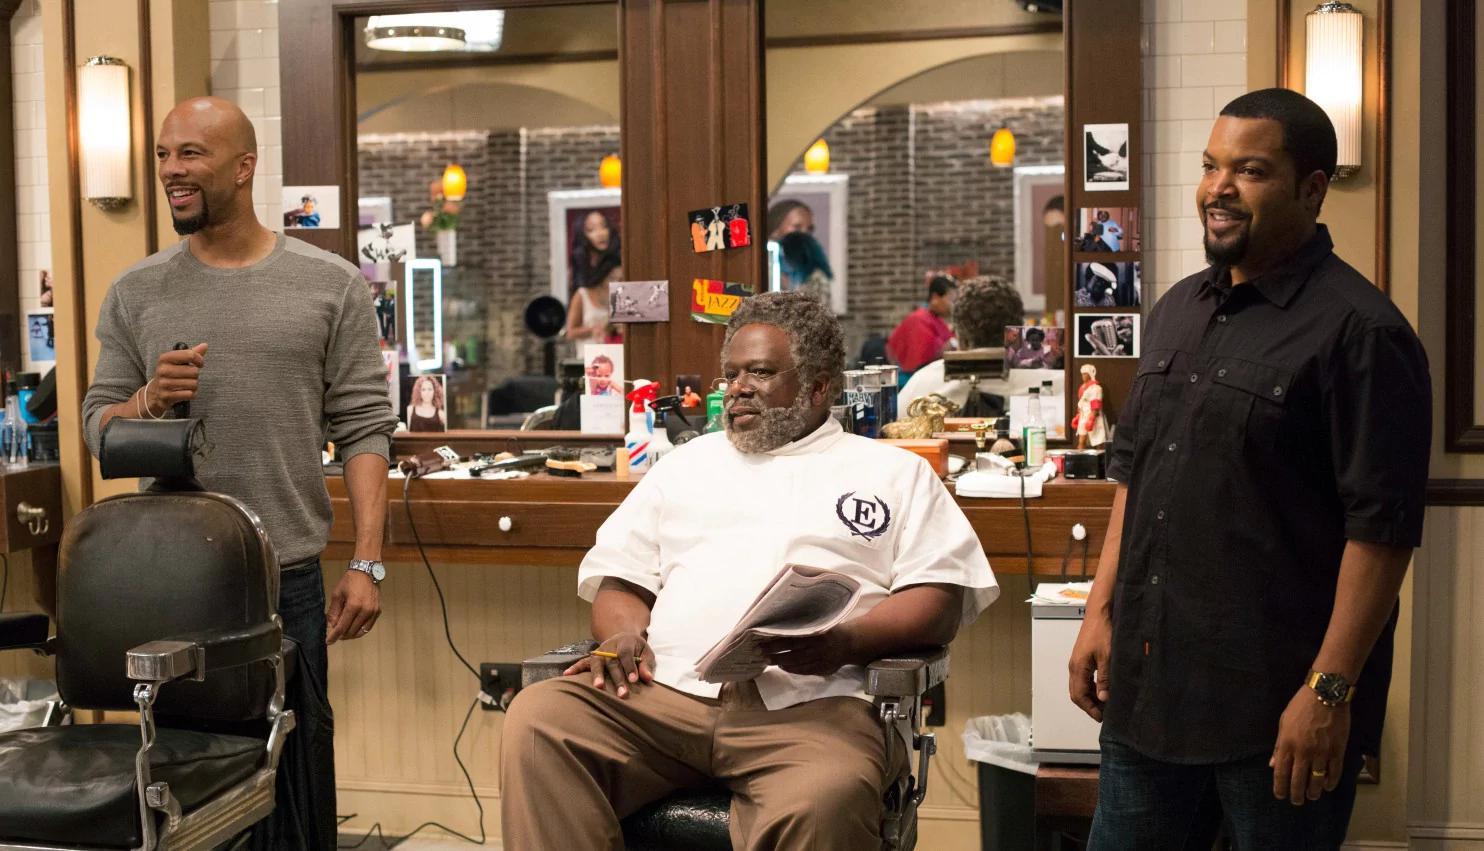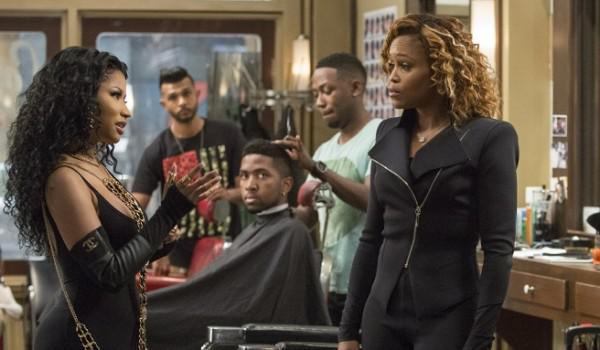The first image is the image on the left, the second image is the image on the right. For the images displayed, is the sentence "There is a woman in red in one of the images." factually correct? Answer yes or no. No. The first image is the image on the left, the second image is the image on the right. Given the left and right images, does the statement "Only men are present in one of the barbershop images." hold true? Answer yes or no. Yes. 